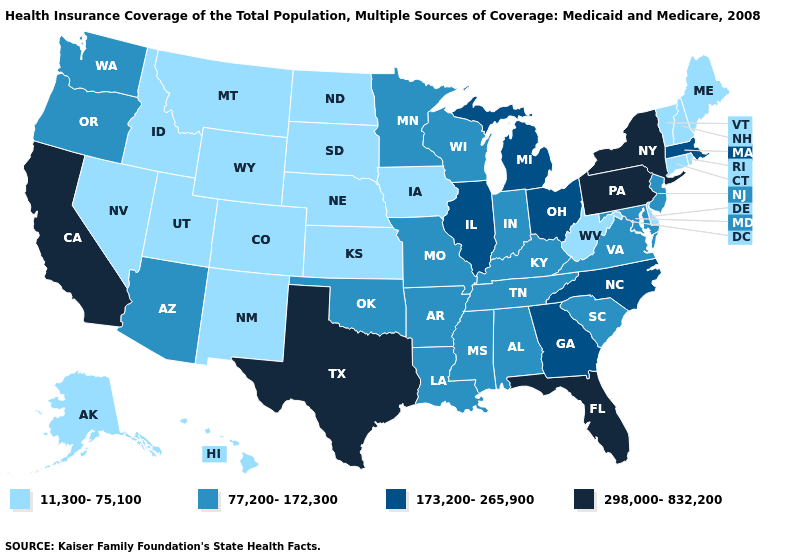What is the highest value in the USA?
Be succinct. 298,000-832,200. Does Mississippi have the same value as Idaho?
Concise answer only. No. Among the states that border Washington , which have the highest value?
Give a very brief answer. Oregon. What is the value of Oklahoma?
Quick response, please. 77,200-172,300. What is the lowest value in states that border Maine?
Be succinct. 11,300-75,100. What is the value of Nevada?
Write a very short answer. 11,300-75,100. What is the highest value in the Northeast ?
Be succinct. 298,000-832,200. What is the lowest value in the USA?
Keep it brief. 11,300-75,100. Which states have the lowest value in the USA?
Quick response, please. Alaska, Colorado, Connecticut, Delaware, Hawaii, Idaho, Iowa, Kansas, Maine, Montana, Nebraska, Nevada, New Hampshire, New Mexico, North Dakota, Rhode Island, South Dakota, Utah, Vermont, West Virginia, Wyoming. What is the highest value in the Northeast ?
Keep it brief. 298,000-832,200. Among the states that border Virginia , which have the lowest value?
Write a very short answer. West Virginia. Does Illinois have the same value as New Mexico?
Be succinct. No. Which states have the lowest value in the South?
Give a very brief answer. Delaware, West Virginia. Name the states that have a value in the range 298,000-832,200?
Keep it brief. California, Florida, New York, Pennsylvania, Texas. What is the highest value in the USA?
Give a very brief answer. 298,000-832,200. 